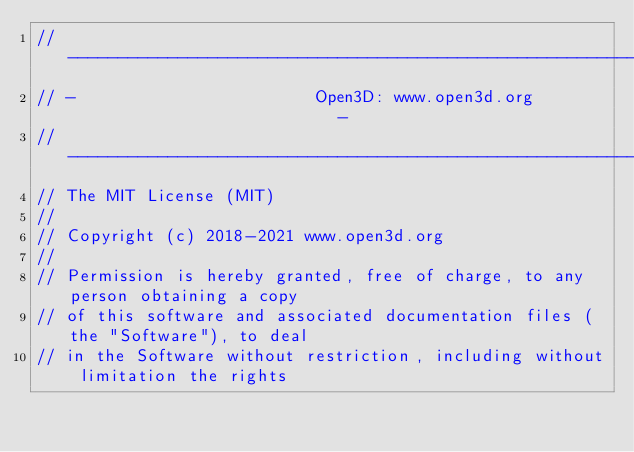<code> <loc_0><loc_0><loc_500><loc_500><_Cuda_>// ----------------------------------------------------------------------------
// -                        Open3D: www.open3d.org                            -
// ----------------------------------------------------------------------------
// The MIT License (MIT)
//
// Copyright (c) 2018-2021 www.open3d.org
//
// Permission is hereby granted, free of charge, to any person obtaining a copy
// of this software and associated documentation files (the "Software"), to deal
// in the Software without restriction, including without limitation the rights</code> 